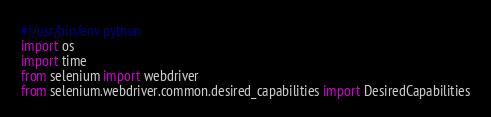<code> <loc_0><loc_0><loc_500><loc_500><_Python_>#!/usr/bin/env python
import os
import time
from selenium import webdriver
from selenium.webdriver.common.desired_capabilities import DesiredCapabilities
</code> 